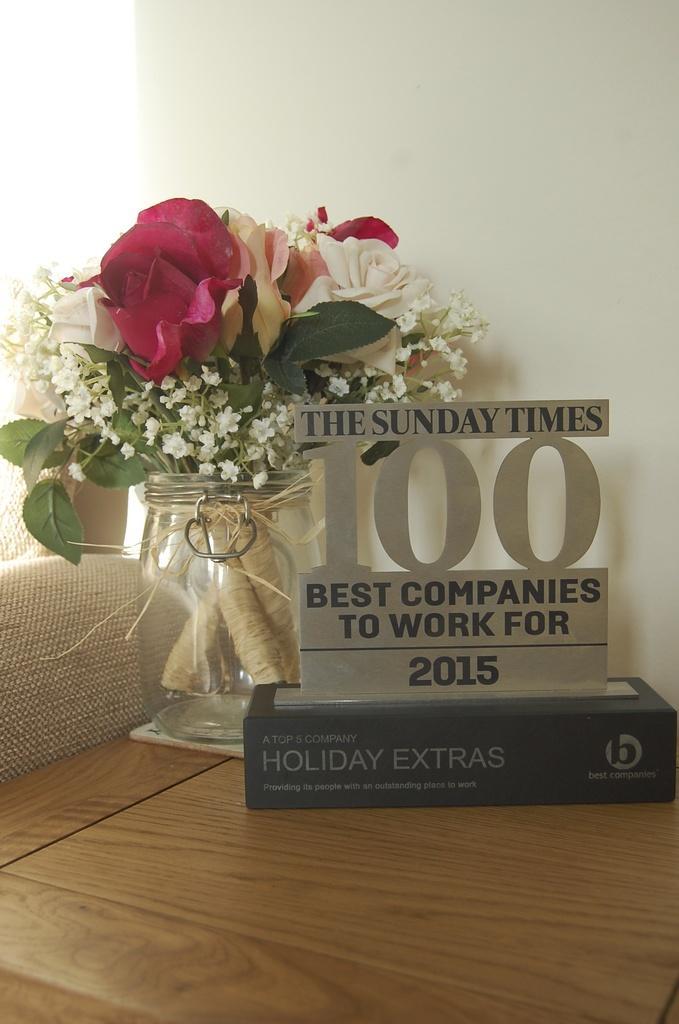How would you summarize this image in a sentence or two? In the picture we can find a table. On the table we can find a award and jar with flowers and leaves. In the background we can find a white wall. 